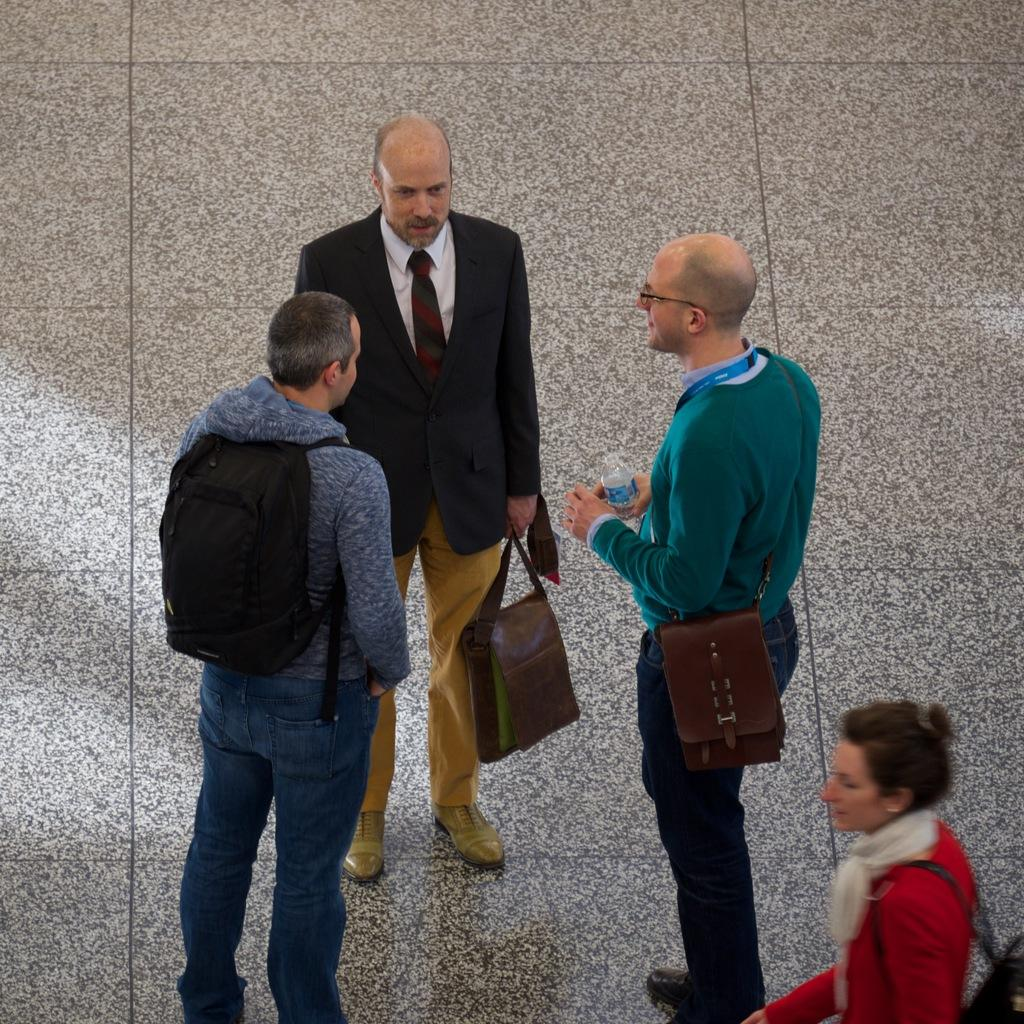How many people are in the image? The number of people in the image cannot be determined from the provided facts. What are the people holding in the image? The people in the image are holding objects. What can be seen beneath the people in the image? The ground is visible in the image. What type of oven is being used to distribute the burst in the image? There is no oven, distribution, or burst present in the image. 